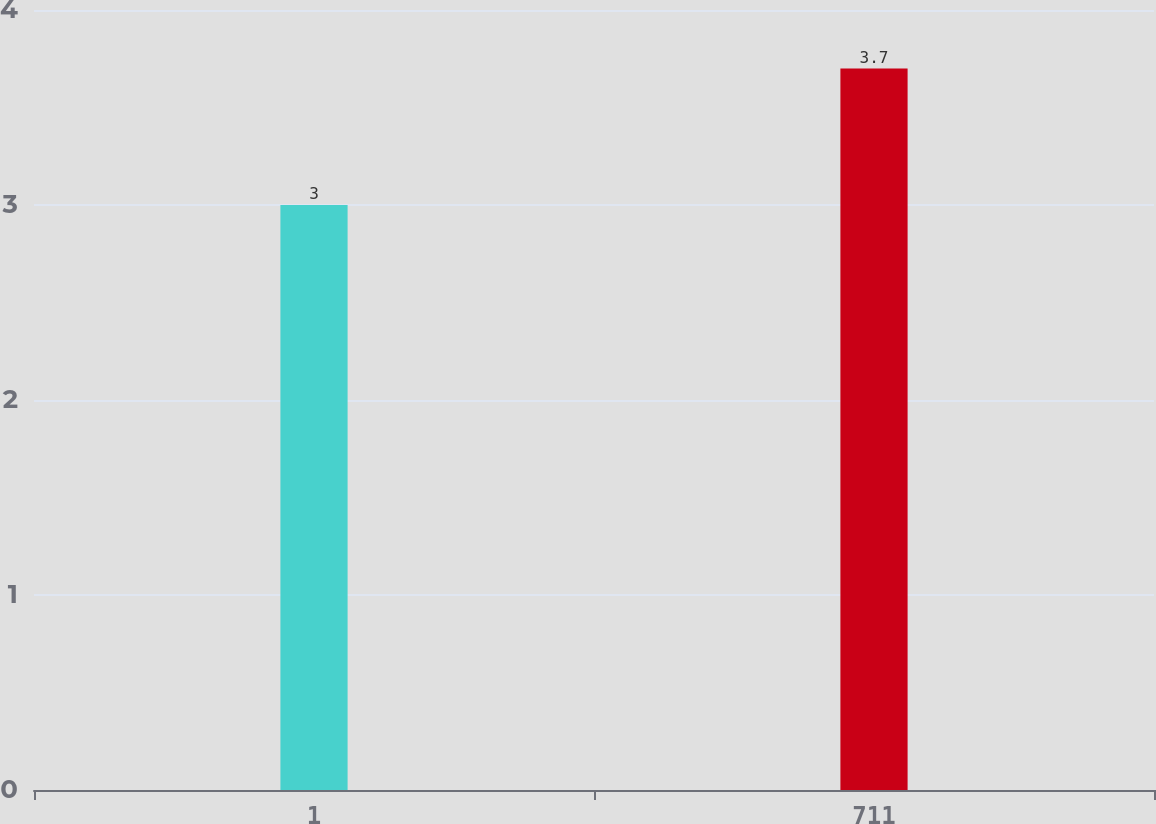Convert chart. <chart><loc_0><loc_0><loc_500><loc_500><bar_chart><fcel>1<fcel>711<nl><fcel>3<fcel>3.7<nl></chart> 